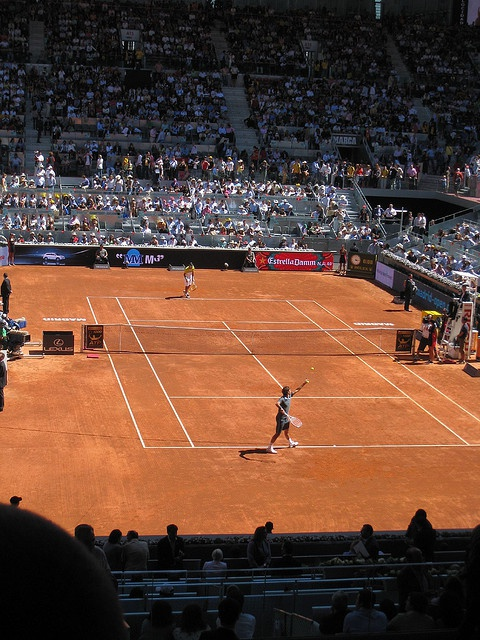Describe the objects in this image and their specific colors. I can see people in black, gray, maroon, and brown tones, people in black, maroon, and brown tones, people in black, gray, and darkblue tones, people in black, maroon, brown, and gray tones, and people in black, salmon, and maroon tones in this image. 